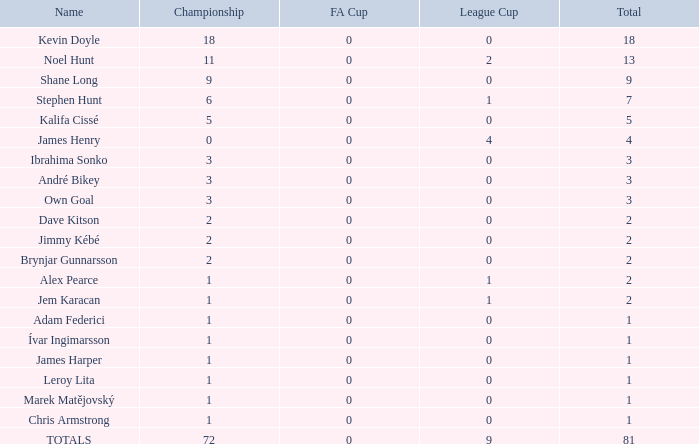What is the cumulative championships where the league cup is below 0? None. 